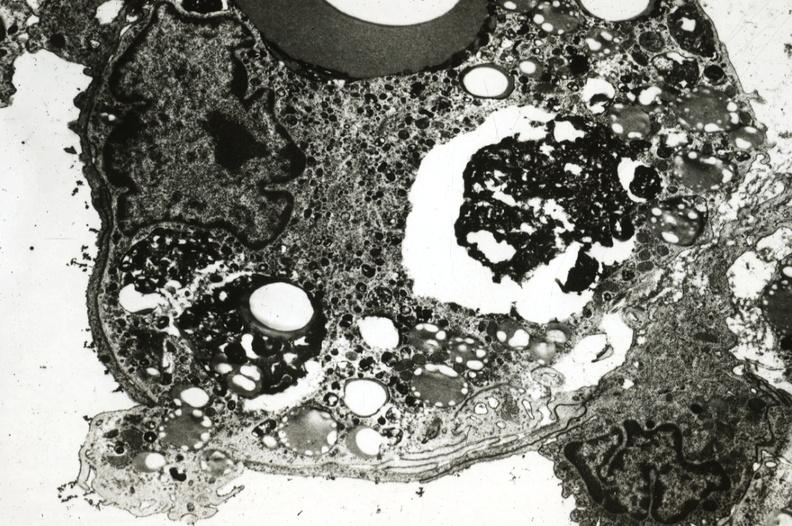what does this image show?
Answer the question using a single word or phrase. Rabbit foam cell with pseudopod extending through endothelium into lumen presumably exiting the aorta 